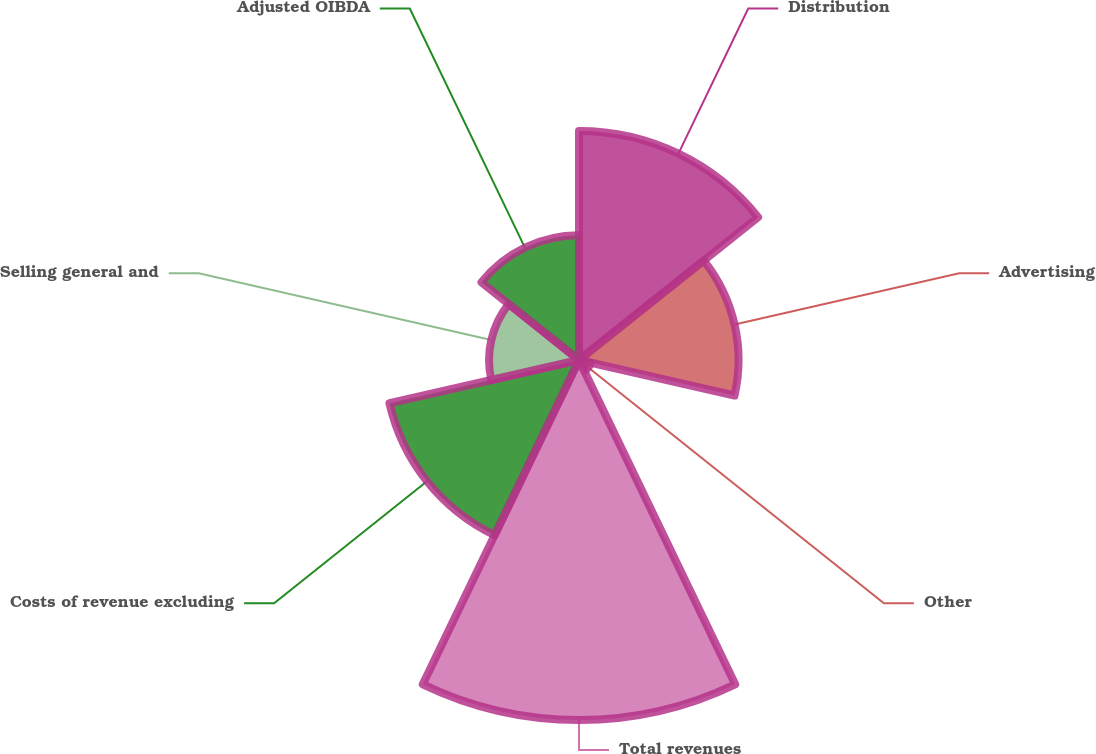Convert chart. <chart><loc_0><loc_0><loc_500><loc_500><pie_chart><fcel>Distribution<fcel>Advertising<fcel>Other<fcel>Total revenues<fcel>Costs of revenue excluding<fcel>Selling general and<fcel>Adjusted OIBDA<nl><fcel>19.59%<fcel>13.64%<fcel>1.02%<fcel>30.78%<fcel>16.62%<fcel>7.69%<fcel>10.66%<nl></chart> 